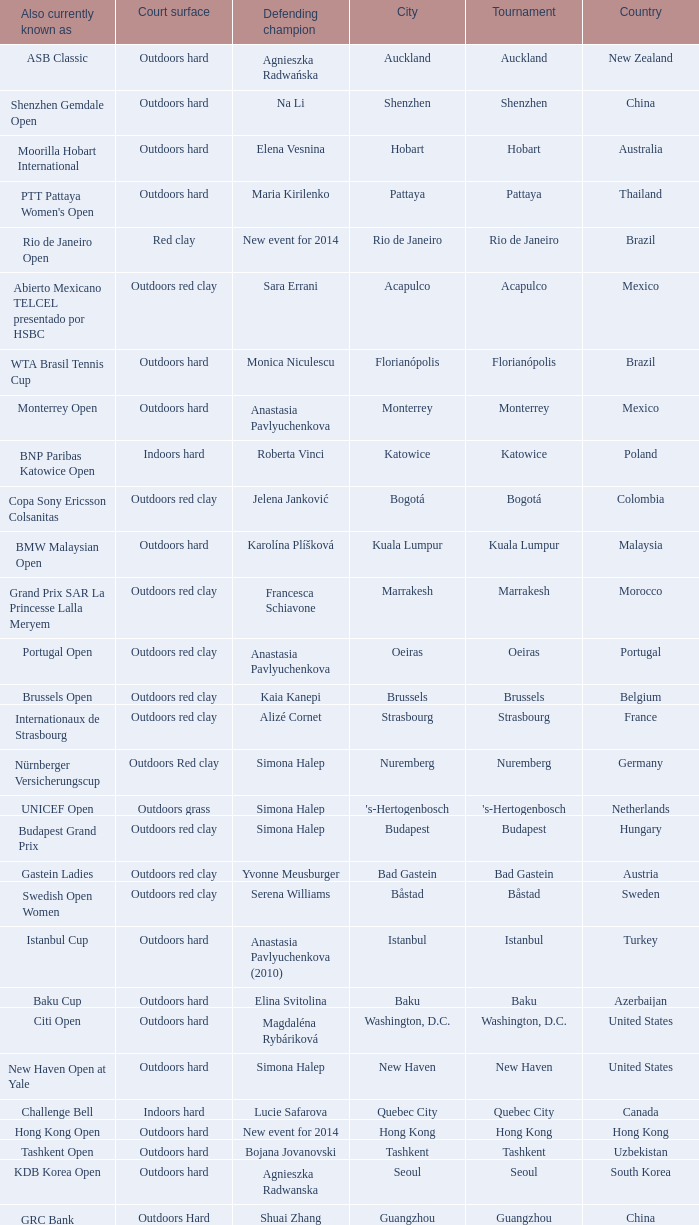How many tournaments are also currently known as the hp open? 1.0. Could you help me parse every detail presented in this table? {'header': ['Also currently known as', 'Court surface', 'Defending champion', 'City', 'Tournament', 'Country'], 'rows': [['ASB Classic', 'Outdoors hard', 'Agnieszka Radwańska', 'Auckland', 'Auckland', 'New Zealand'], ['Shenzhen Gemdale Open', 'Outdoors hard', 'Na Li', 'Shenzhen', 'Shenzhen', 'China'], ['Moorilla Hobart International', 'Outdoors hard', 'Elena Vesnina', 'Hobart', 'Hobart', 'Australia'], ["PTT Pattaya Women's Open", 'Outdoors hard', 'Maria Kirilenko', 'Pattaya', 'Pattaya', 'Thailand'], ['Rio de Janeiro Open', 'Red clay', 'New event for 2014', 'Rio de Janeiro', 'Rio de Janeiro', 'Brazil'], ['Abierto Mexicano TELCEL presentado por HSBC', 'Outdoors red clay', 'Sara Errani', 'Acapulco', 'Acapulco', 'Mexico'], ['WTA Brasil Tennis Cup', 'Outdoors hard', 'Monica Niculescu', 'Florianópolis', 'Florianópolis', 'Brazil'], ['Monterrey Open', 'Outdoors hard', 'Anastasia Pavlyuchenkova', 'Monterrey', 'Monterrey', 'Mexico'], ['BNP Paribas Katowice Open', 'Indoors hard', 'Roberta Vinci', 'Katowice', 'Katowice', 'Poland'], ['Copa Sony Ericsson Colsanitas', 'Outdoors red clay', 'Jelena Janković', 'Bogotá', 'Bogotá', 'Colombia'], ['BMW Malaysian Open', 'Outdoors hard', 'Karolína Plíšková', 'Kuala Lumpur', 'Kuala Lumpur', 'Malaysia'], ['Grand Prix SAR La Princesse Lalla Meryem', 'Outdoors red clay', 'Francesca Schiavone', 'Marrakesh', 'Marrakesh', 'Morocco'], ['Portugal Open', 'Outdoors red clay', 'Anastasia Pavlyuchenkova', 'Oeiras', 'Oeiras', 'Portugal'], ['Brussels Open', 'Outdoors red clay', 'Kaia Kanepi', 'Brussels', 'Brussels', 'Belgium'], ['Internationaux de Strasbourg', 'Outdoors red clay', 'Alizé Cornet', 'Strasbourg', 'Strasbourg', 'France'], ['Nürnberger Versicherungscup', 'Outdoors Red clay', 'Simona Halep', 'Nuremberg', 'Nuremberg', 'Germany'], ['UNICEF Open', 'Outdoors grass', 'Simona Halep', "'s-Hertogenbosch", "'s-Hertogenbosch", 'Netherlands'], ['Budapest Grand Prix', 'Outdoors red clay', 'Simona Halep', 'Budapest', 'Budapest', 'Hungary'], ['Gastein Ladies', 'Outdoors red clay', 'Yvonne Meusburger', 'Bad Gastein', 'Bad Gastein', 'Austria'], ['Swedish Open Women', 'Outdoors red clay', 'Serena Williams', 'Båstad', 'Båstad', 'Sweden'], ['Istanbul Cup', 'Outdoors hard', 'Anastasia Pavlyuchenkova (2010)', 'Istanbul', 'Istanbul', 'Turkey'], ['Baku Cup', 'Outdoors hard', 'Elina Svitolina', 'Baku', 'Baku', 'Azerbaijan'], ['Citi Open', 'Outdoors hard', 'Magdaléna Rybáriková', 'Washington, D.C.', 'Washington, D.C.', 'United States'], ['New Haven Open at Yale', 'Outdoors hard', 'Simona Halep', 'New Haven', 'New Haven', 'United States'], ['Challenge Bell', 'Indoors hard', 'Lucie Safarova', 'Quebec City', 'Quebec City', 'Canada'], ['Hong Kong Open', 'Outdoors hard', 'New event for 2014', 'Hong Kong', 'Hong Kong', 'Hong Kong'], ['Tashkent Open', 'Outdoors hard', 'Bojana Jovanovski', 'Tashkent', 'Tashkent', 'Uzbekistan'], ['KDB Korea Open', 'Outdoors hard', 'Agnieszka Radwanska', 'Seoul', 'Seoul', 'South Korea'], ["GRC Bank Guangzhou International Women's Open", 'Outdoors Hard', 'Shuai Zhang', 'Guangzhou', 'Guangzhou', 'China'], ['Generali Ladies Linz', 'Indoors hard', 'Angelique Kerber', 'Linz', 'Linz', 'Austria'], ['HP Open', 'Outdoors hard', 'Samantha Stosur', 'Osaka', 'Osaka', 'Japan'], ['BGL Luxembourg Open', 'Indoors hard', 'Caroline Wozniacki', 'Luxembourg City', 'Luxembourg', 'Luxembourg']]} 